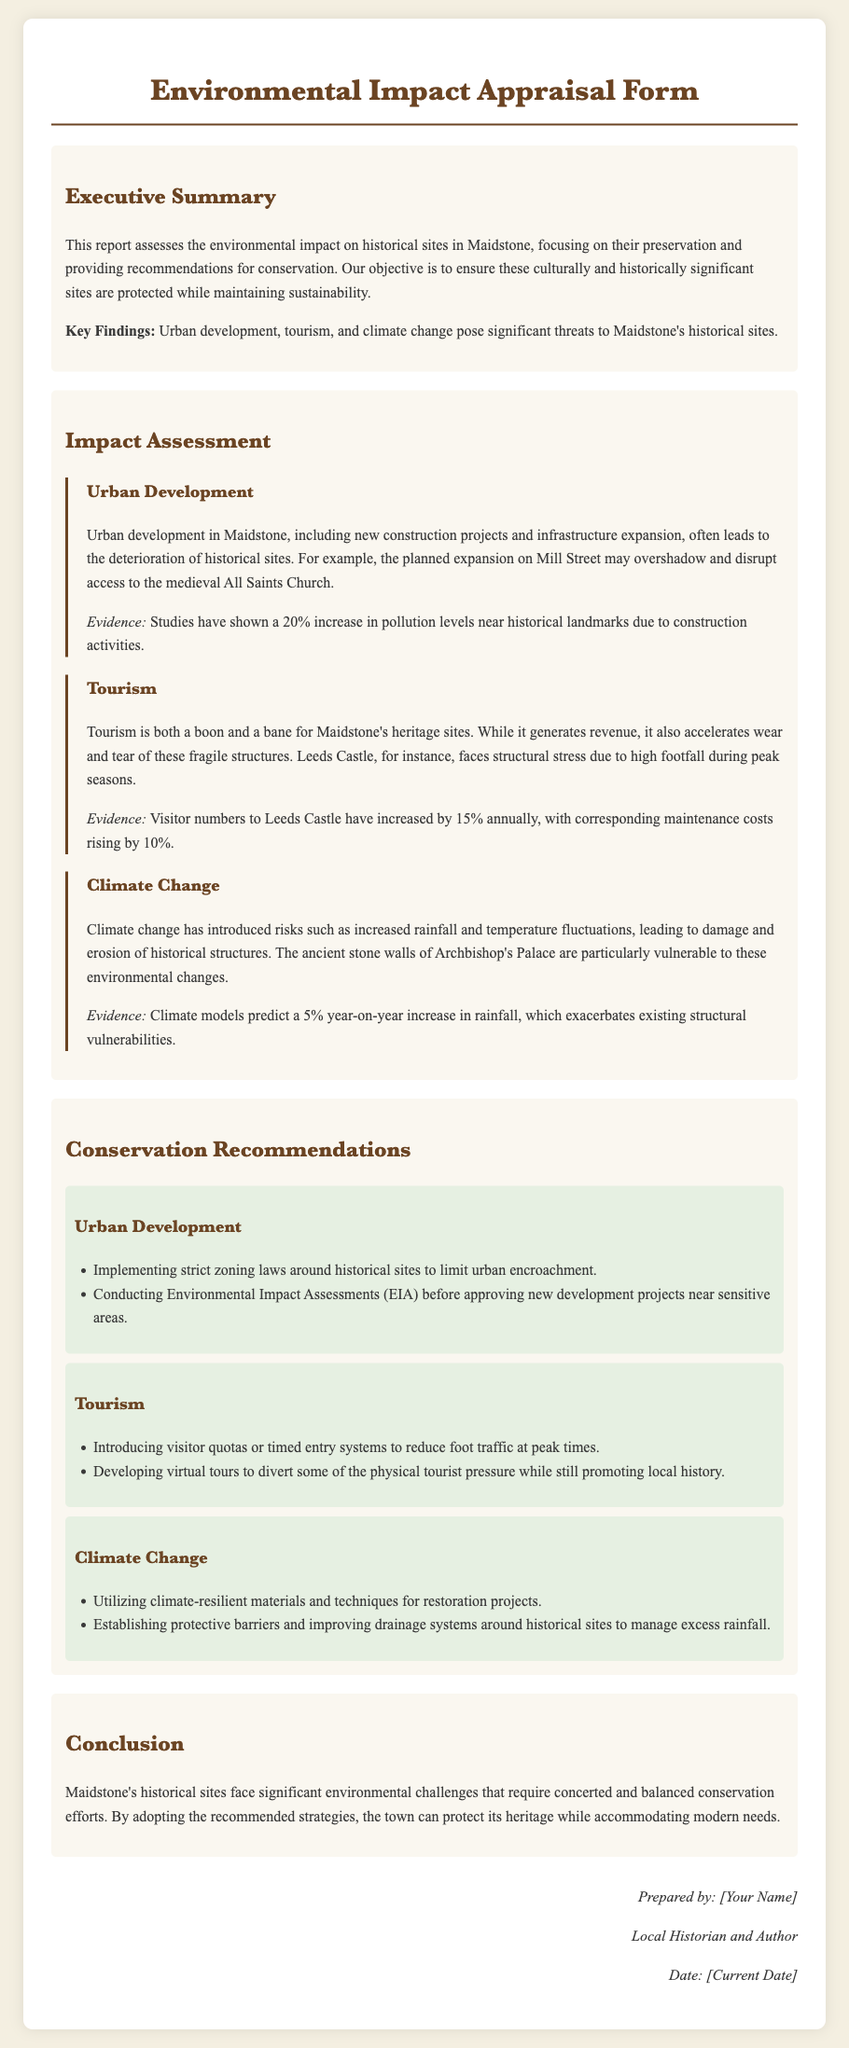What is the purpose of the report? The report assesses the environmental impact on historical sites in Maidstone, focusing on their preservation and providing recommendations for conservation.
Answer: Preservation and conservation recommendations What is a significant threat to Maidstone's historical sites? The report mentions urban development, tourism, and climate change as significant threats.
Answer: Urban development What percentage increase in pollution levels has been reported near landmarks due to construction? The document states a 20% increase in pollution levels is observed.
Answer: 20% What does the report recommend for urban development? The recommendations include implementing strict zoning laws and conducting Environmental Impact Assessments.
Answer: Zoning laws and EIA What is the predicted year-on-year increase in rainfall according to climate models? The climate models predict a 5% year-on-year increase in rainfall.
Answer: 5% What impact does tourism have on Leeds Castle? Tourism is noted to create structural stress on Leeds Castle due to high visitor numbers.
Answer: Structural stress How does the report suggest managing excess rainfall? One of the recommendations is establishing protective barriers and improving drainage systems.
Answer: Protective barriers What does the Executive Summary highlight about key findings? The Executive Summary highlights that urban development, tourism, and climate change pose significant threats.
Answer: Significant threats What is one recommendation to reduce foot traffic during peak times? The report suggests introducing visitor quotas or timed entry systems.
Answer: Visitor quotas or timed entry systems 